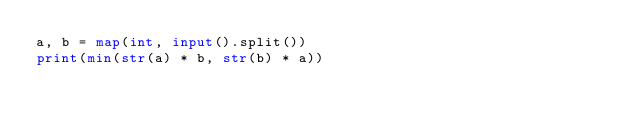<code> <loc_0><loc_0><loc_500><loc_500><_Python_>a, b = map(int, input().split())
print(min(str(a) * b, str(b) * a))</code> 